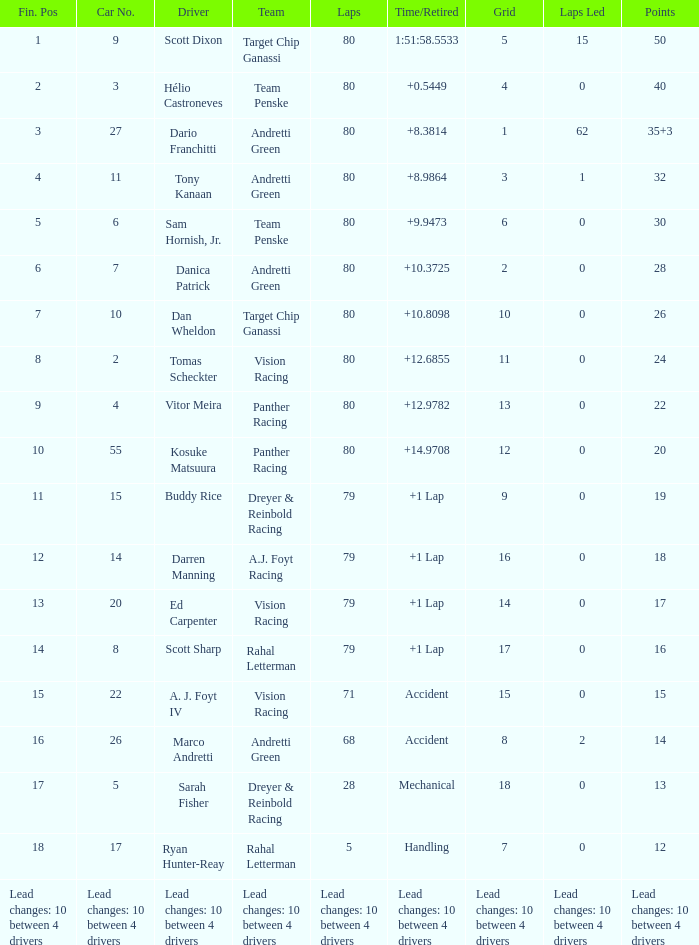What network has 24 points? 11.0. 